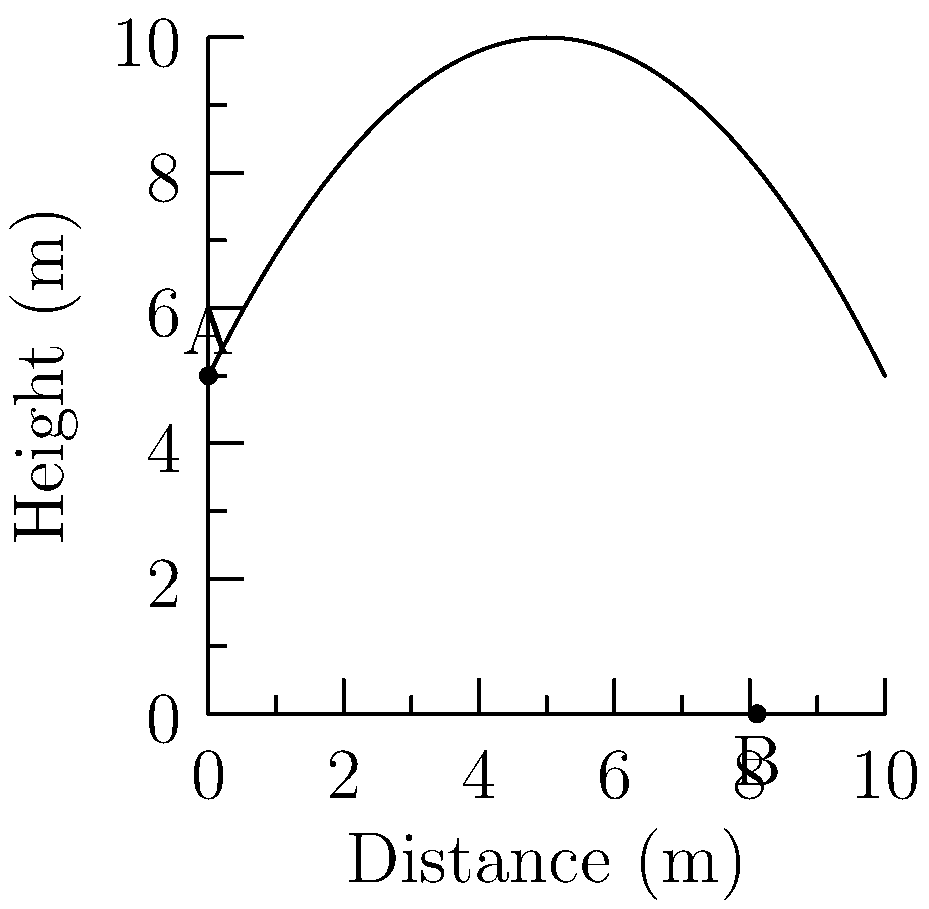In a local javelin throw competition, the trajectory of a javelin is represented by the parabolic curve shown in the graph. The curve is described by the equation $h(x) = -0.2x^2 + 2x + 5$, where $h$ is the height in meters and $x$ is the horizontal distance in meters. What is the maximum height reached by the javelin during its flight? To find the maximum height of the javelin's trajectory, we need to follow these steps:

1) The parabola opens downward because the coefficient of $x^2$ is negative. This means the vertex of the parabola represents the highest point.

2) For a quadratic function in the form $f(x) = ax^2 + bx + c$, the x-coordinate of the vertex is given by $x = -\frac{b}{2a}$.

3) In our equation $h(x) = -0.2x^2 + 2x + 5$:
   $a = -0.2$
   $b = 2$
   $c = 5$

4) Plugging into the formula:
   $x = -\frac{2}{2(-0.2)} = -\frac{2}{-0.4} = 5$

5) To find the maximum height, we need to calculate $h(5)$:
   $h(5) = -0.2(5)^2 + 2(5) + 5$
   $= -0.2(25) + 10 + 5$
   $= -5 + 10 + 5$
   $= 10$

Therefore, the maximum height reached by the javelin is 10 meters.
Answer: 10 meters 